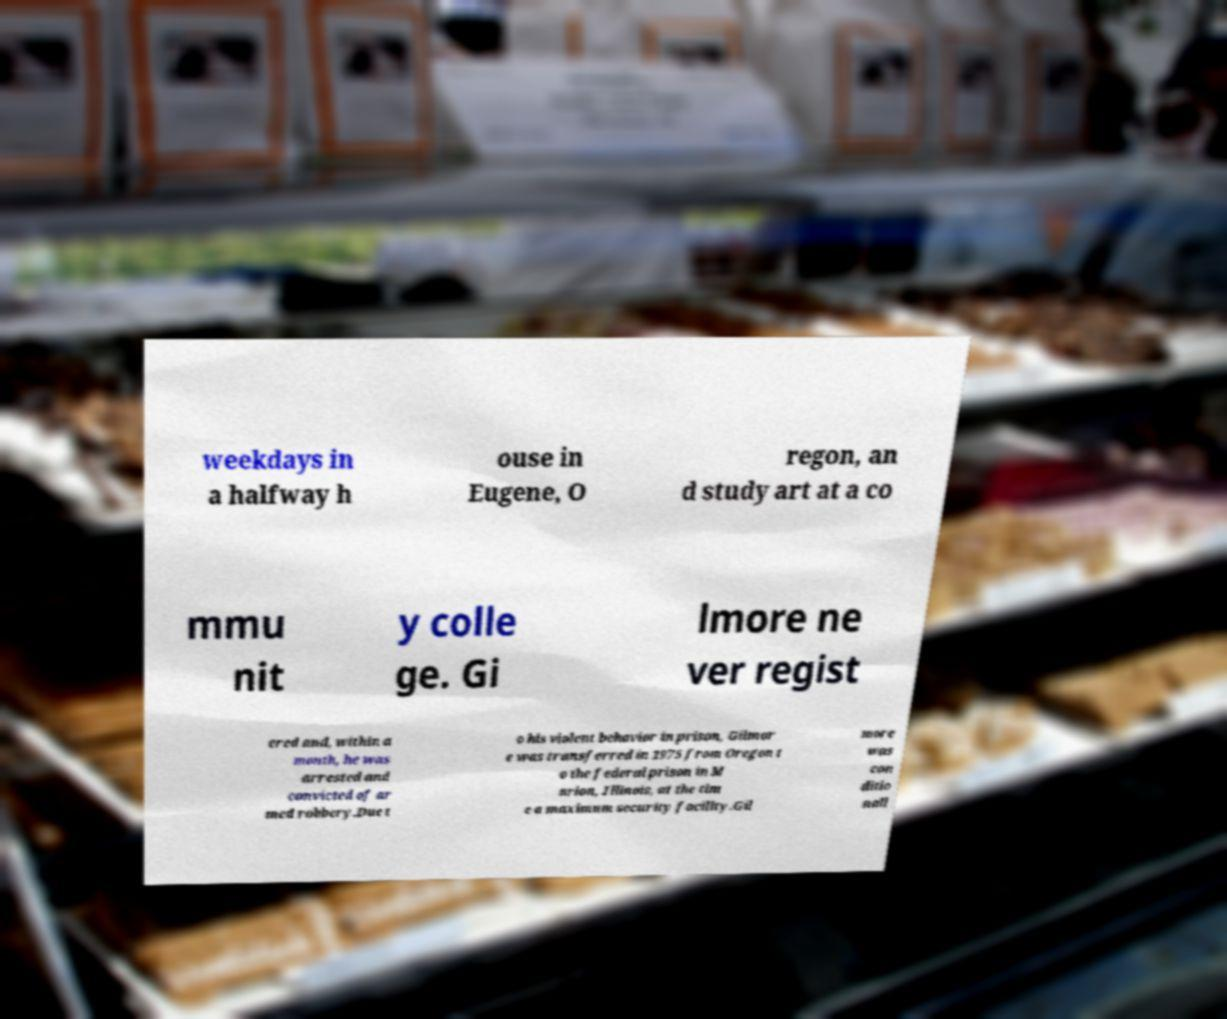Can you read and provide the text displayed in the image?This photo seems to have some interesting text. Can you extract and type it out for me? weekdays in a halfway h ouse in Eugene, O regon, an d study art at a co mmu nit y colle ge. Gi lmore ne ver regist ered and, within a month, he was arrested and convicted of ar med robbery.Due t o his violent behavior in prison, Gilmor e was transferred in 1975 from Oregon t o the federal prison in M arion, Illinois, at the tim e a maximum security facility.Gil more was con ditio nall 